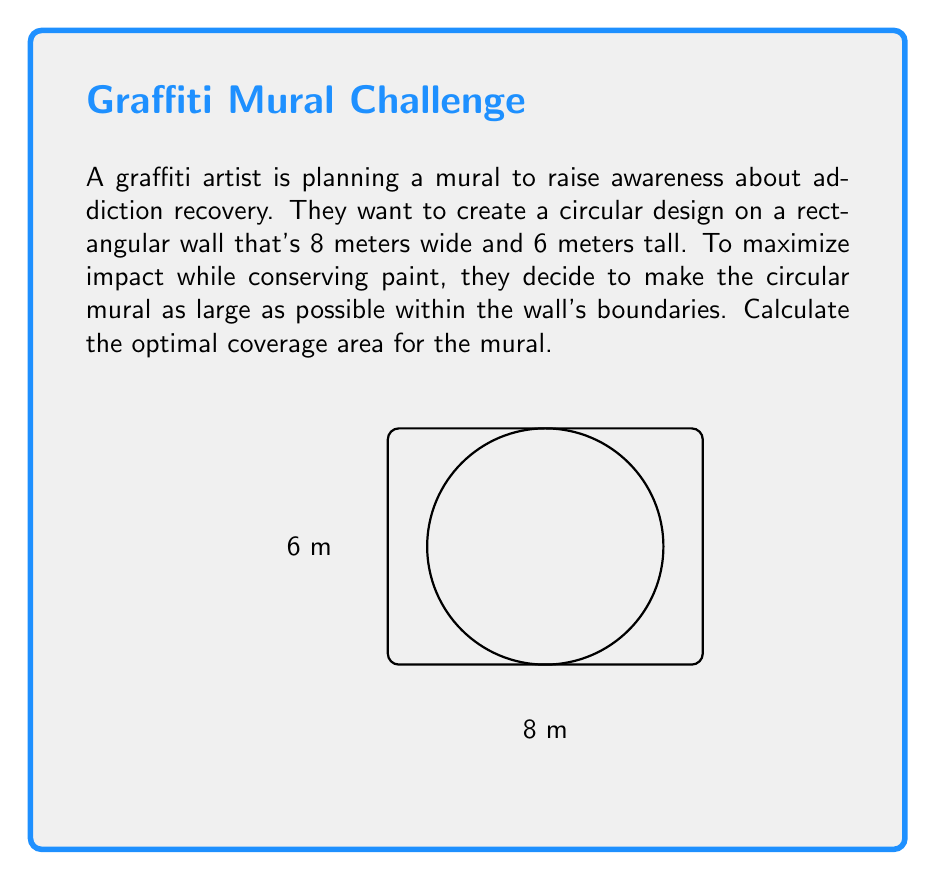What is the answer to this math problem? Let's approach this step-by-step:

1) The largest circle that can fit inside the rectangular wall will have a diameter equal to the shorter side of the rectangle. In this case, the height of 6 meters.

2) The radius of this circle will be half of the diameter:
   $r = \frac{6}{2} = 3$ meters

3) The area of a circle is given by the formula:
   $A = \pi r^2$

4) Substituting our radius:
   $A = \pi (3)^2$
   $A = 9\pi$ square meters

5) To calculate the exact value:
   $A = 9 \times 3.14159...$
   $A \approx 28.27$ square meters

Therefore, the optimal coverage area for the mural is $9\pi$ or approximately 28.27 square meters.
Answer: $9\pi$ m² 